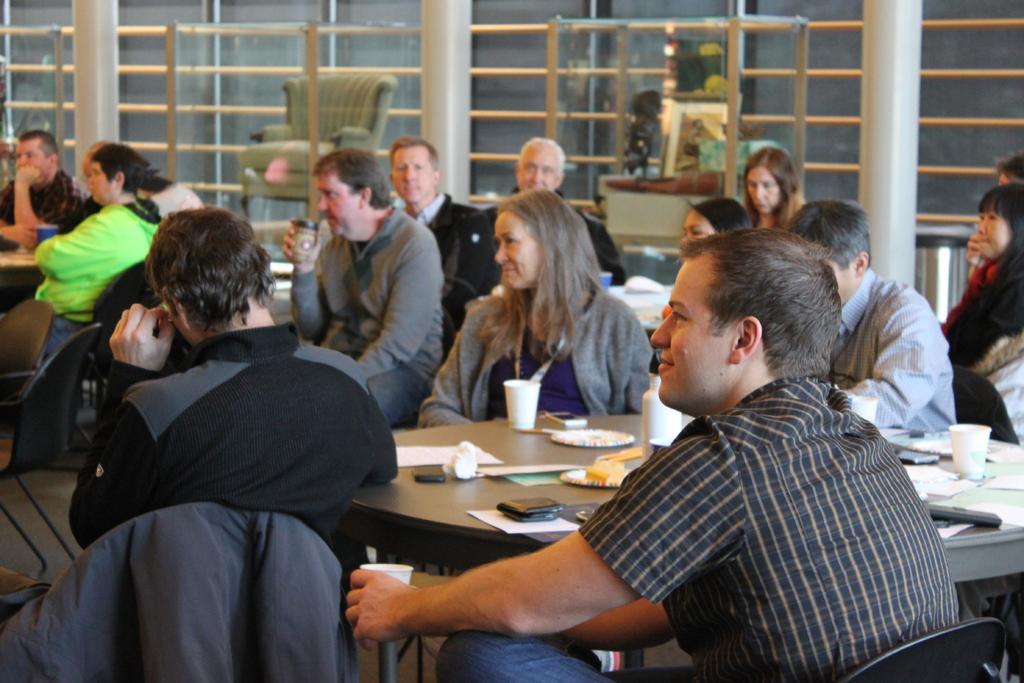How would you summarize this image in a sentence or two? In this image we can see people sitting on the chairs and we can also see windows and some other objects placed on the table. 